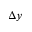<formula> <loc_0><loc_0><loc_500><loc_500>\Delta y</formula> 